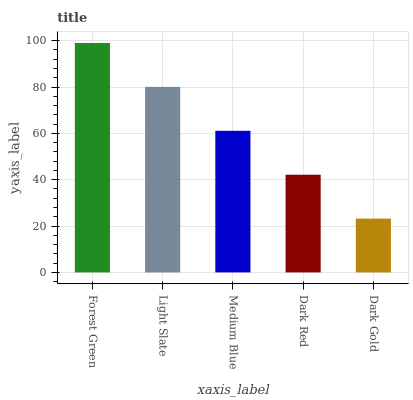Is Dark Gold the minimum?
Answer yes or no. Yes. Is Forest Green the maximum?
Answer yes or no. Yes. Is Light Slate the minimum?
Answer yes or no. No. Is Light Slate the maximum?
Answer yes or no. No. Is Forest Green greater than Light Slate?
Answer yes or no. Yes. Is Light Slate less than Forest Green?
Answer yes or no. Yes. Is Light Slate greater than Forest Green?
Answer yes or no. No. Is Forest Green less than Light Slate?
Answer yes or no. No. Is Medium Blue the high median?
Answer yes or no. Yes. Is Medium Blue the low median?
Answer yes or no. Yes. Is Dark Red the high median?
Answer yes or no. No. Is Dark Red the low median?
Answer yes or no. No. 